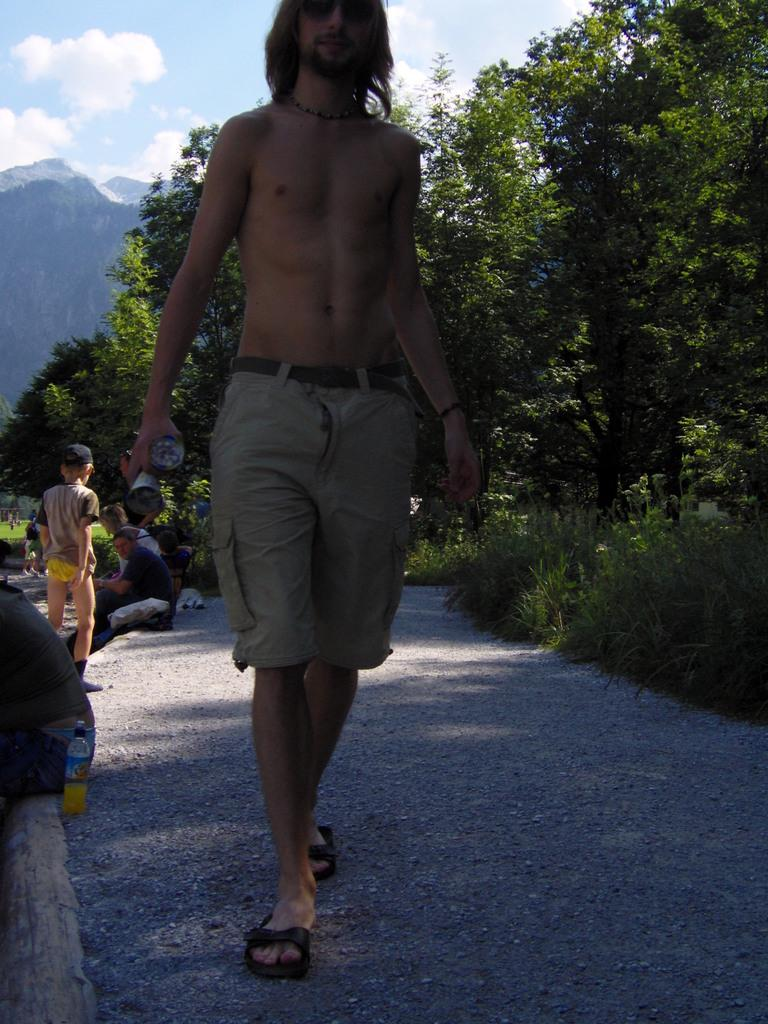How many people are in the image? There is a group of people in the image, but the exact number is not specified. What are the people wearing in the image? The people in the image are wearing dresses. What can be seen in the background of the image? There are trees, mountains, clouds, and the sky visible in the background of the image. What type of hair is visible on the swing in the image? There is no swing present in the image, and therefore no hair can be seen on it. 